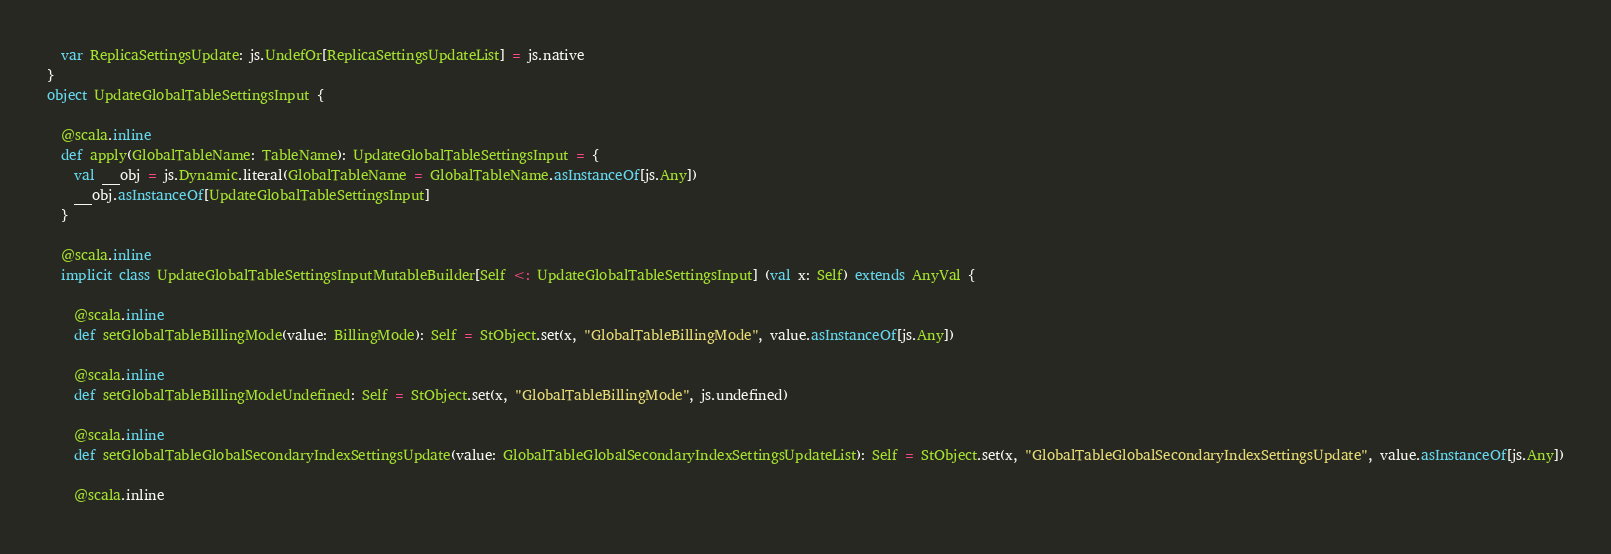Convert code to text. <code><loc_0><loc_0><loc_500><loc_500><_Scala_>  var ReplicaSettingsUpdate: js.UndefOr[ReplicaSettingsUpdateList] = js.native
}
object UpdateGlobalTableSettingsInput {
  
  @scala.inline
  def apply(GlobalTableName: TableName): UpdateGlobalTableSettingsInput = {
    val __obj = js.Dynamic.literal(GlobalTableName = GlobalTableName.asInstanceOf[js.Any])
    __obj.asInstanceOf[UpdateGlobalTableSettingsInput]
  }
  
  @scala.inline
  implicit class UpdateGlobalTableSettingsInputMutableBuilder[Self <: UpdateGlobalTableSettingsInput] (val x: Self) extends AnyVal {
    
    @scala.inline
    def setGlobalTableBillingMode(value: BillingMode): Self = StObject.set(x, "GlobalTableBillingMode", value.asInstanceOf[js.Any])
    
    @scala.inline
    def setGlobalTableBillingModeUndefined: Self = StObject.set(x, "GlobalTableBillingMode", js.undefined)
    
    @scala.inline
    def setGlobalTableGlobalSecondaryIndexSettingsUpdate(value: GlobalTableGlobalSecondaryIndexSettingsUpdateList): Self = StObject.set(x, "GlobalTableGlobalSecondaryIndexSettingsUpdate", value.asInstanceOf[js.Any])
    
    @scala.inline</code> 